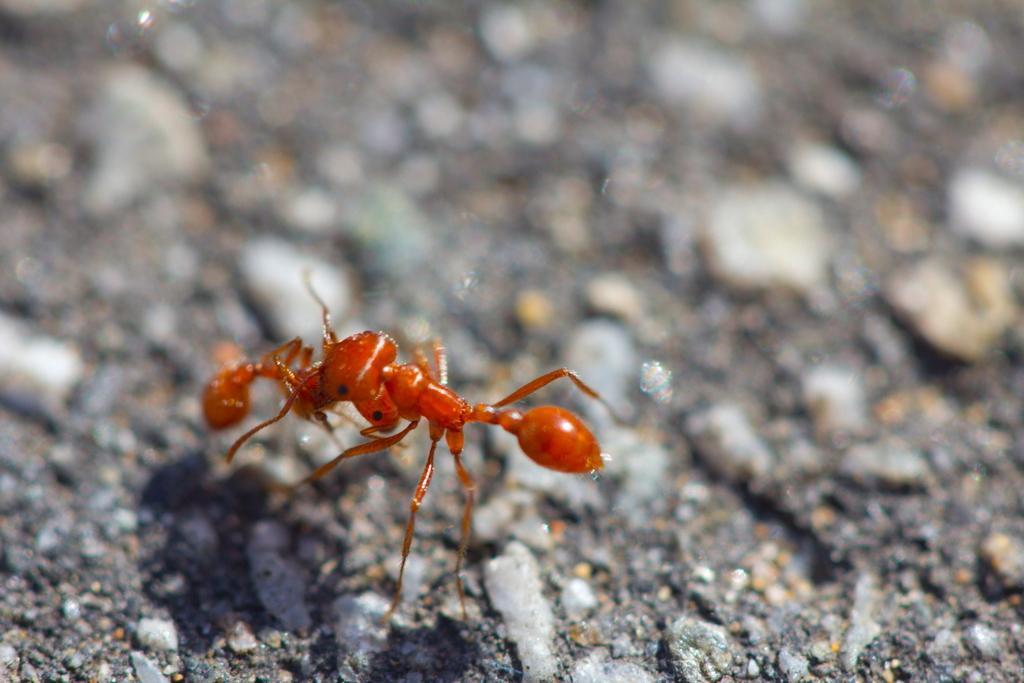Can you describe this image briefly? In this image I can see an insect in brown color and I can see blurred background. 